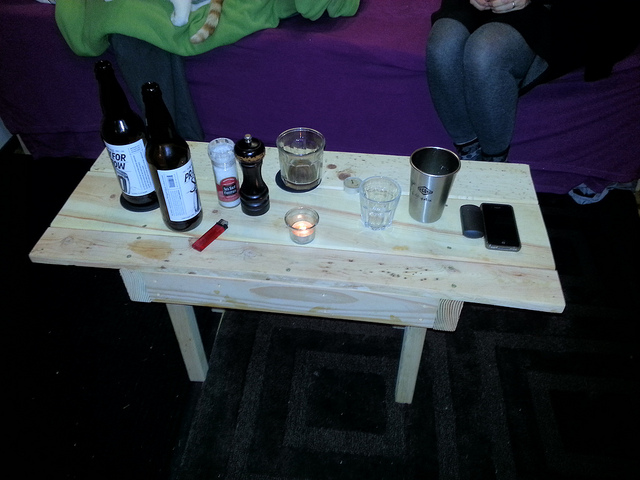How many bottles can you see? 2 